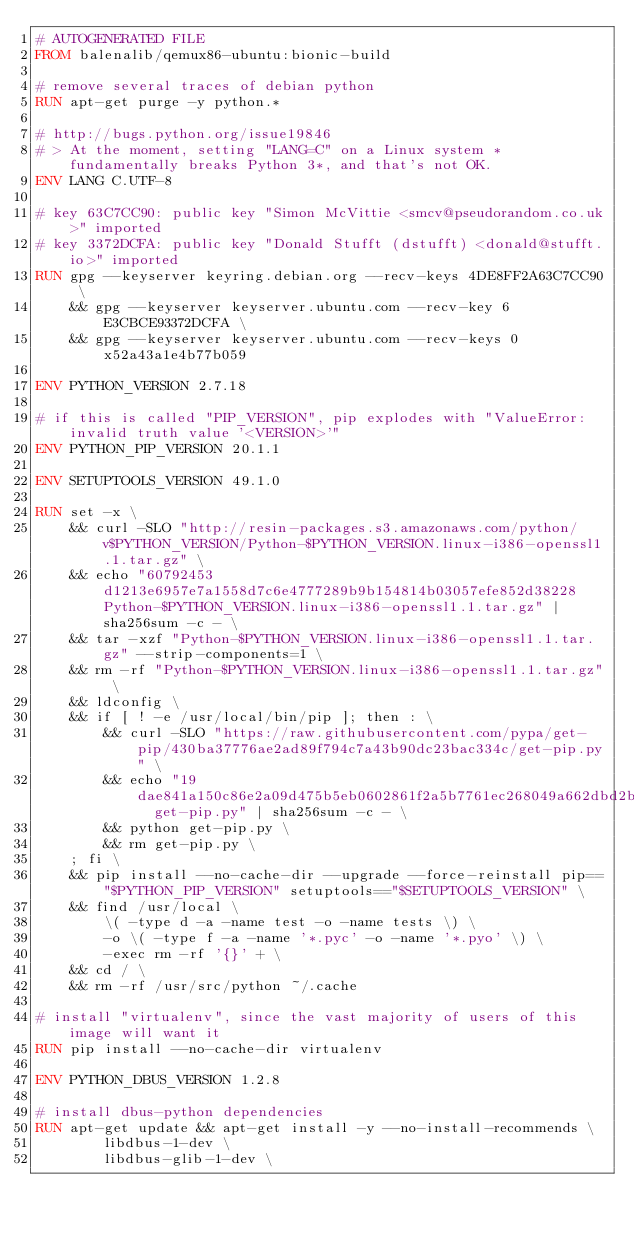Convert code to text. <code><loc_0><loc_0><loc_500><loc_500><_Dockerfile_># AUTOGENERATED FILE
FROM balenalib/qemux86-ubuntu:bionic-build

# remove several traces of debian python
RUN apt-get purge -y python.*

# http://bugs.python.org/issue19846
# > At the moment, setting "LANG=C" on a Linux system *fundamentally breaks Python 3*, and that's not OK.
ENV LANG C.UTF-8

# key 63C7CC90: public key "Simon McVittie <smcv@pseudorandom.co.uk>" imported
# key 3372DCFA: public key "Donald Stufft (dstufft) <donald@stufft.io>" imported
RUN gpg --keyserver keyring.debian.org --recv-keys 4DE8FF2A63C7CC90 \
	&& gpg --keyserver keyserver.ubuntu.com --recv-key 6E3CBCE93372DCFA \
	&& gpg --keyserver keyserver.ubuntu.com --recv-keys 0x52a43a1e4b77b059

ENV PYTHON_VERSION 2.7.18

# if this is called "PIP_VERSION", pip explodes with "ValueError: invalid truth value '<VERSION>'"
ENV PYTHON_PIP_VERSION 20.1.1

ENV SETUPTOOLS_VERSION 49.1.0

RUN set -x \
	&& curl -SLO "http://resin-packages.s3.amazonaws.com/python/v$PYTHON_VERSION/Python-$PYTHON_VERSION.linux-i386-openssl1.1.tar.gz" \
	&& echo "60792453d1213e6957e7a1558d7c6e4777289b9b154814b03057efe852d38228  Python-$PYTHON_VERSION.linux-i386-openssl1.1.tar.gz" | sha256sum -c - \
	&& tar -xzf "Python-$PYTHON_VERSION.linux-i386-openssl1.1.tar.gz" --strip-components=1 \
	&& rm -rf "Python-$PYTHON_VERSION.linux-i386-openssl1.1.tar.gz" \
	&& ldconfig \
	&& if [ ! -e /usr/local/bin/pip ]; then : \
		&& curl -SLO "https://raw.githubusercontent.com/pypa/get-pip/430ba37776ae2ad89f794c7a43b90dc23bac334c/get-pip.py" \
		&& echo "19dae841a150c86e2a09d475b5eb0602861f2a5b7761ec268049a662dbd2bd0c  get-pip.py" | sha256sum -c - \
		&& python get-pip.py \
		&& rm get-pip.py \
	; fi \
	&& pip install --no-cache-dir --upgrade --force-reinstall pip=="$PYTHON_PIP_VERSION" setuptools=="$SETUPTOOLS_VERSION" \
	&& find /usr/local \
		\( -type d -a -name test -o -name tests \) \
		-o \( -type f -a -name '*.pyc' -o -name '*.pyo' \) \
		-exec rm -rf '{}' + \
	&& cd / \
	&& rm -rf /usr/src/python ~/.cache

# install "virtualenv", since the vast majority of users of this image will want it
RUN pip install --no-cache-dir virtualenv

ENV PYTHON_DBUS_VERSION 1.2.8

# install dbus-python dependencies 
RUN apt-get update && apt-get install -y --no-install-recommends \
		libdbus-1-dev \
		libdbus-glib-1-dev \</code> 